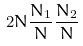<formula> <loc_0><loc_0><loc_500><loc_500>2 N \frac { N _ { 1 } } { N } \frac { N _ { 2 } } { N }</formula> 